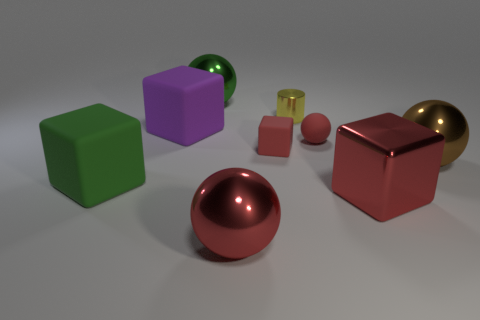There is a matte block in front of the big brown ball; are there any red metallic objects that are behind it?
Give a very brief answer. No. What number of green objects are either matte cubes or cylinders?
Provide a short and direct response. 1. The matte ball has what color?
Your response must be concise. Red. The ball that is the same material as the purple thing is what size?
Keep it short and to the point. Small. How many large green metallic objects are the same shape as the big brown thing?
Your answer should be compact. 1. Are there any other things that have the same size as the green metal sphere?
Your response must be concise. Yes. There is a yellow cylinder that is left of the metal sphere on the right side of the small rubber cube; how big is it?
Ensure brevity in your answer.  Small. What material is the other purple cube that is the same size as the shiny cube?
Make the answer very short. Rubber. Are there any small cubes made of the same material as the yellow cylinder?
Provide a short and direct response. No. There is a sphere to the right of the big red shiny thing that is behind the big red metal thing that is left of the tiny red block; what is its color?
Offer a terse response. Brown. 